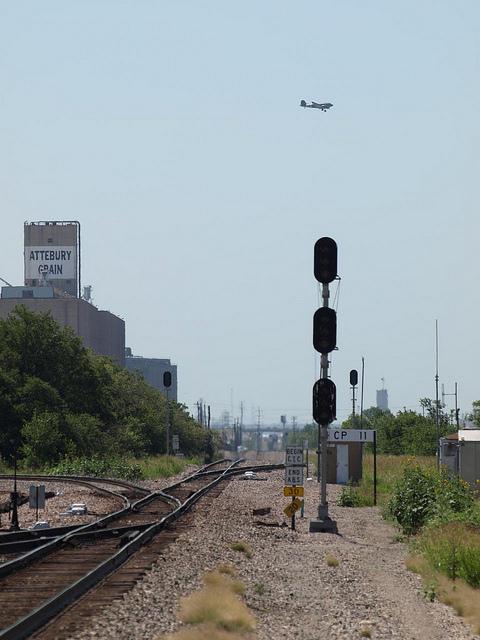What does the giant sign say?
Short answer required. Attebury grain. Might one assume an airport is nearby?
Be succinct. Yes. What is the tallest structure in this photo?
Answer briefly. Building. How many rail tracks are there?
Keep it brief. 3. 